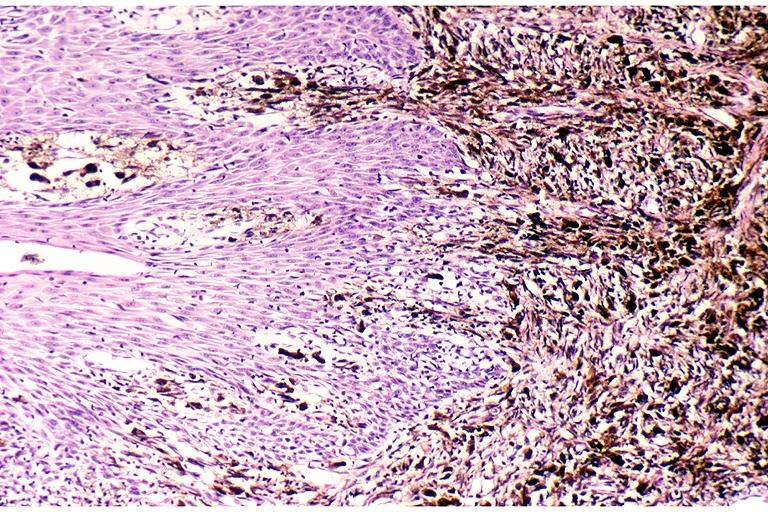s micrognathia triploid fetus present?
Answer the question using a single word or phrase. No 